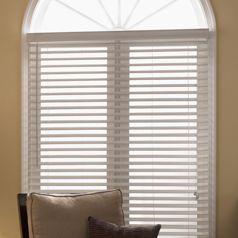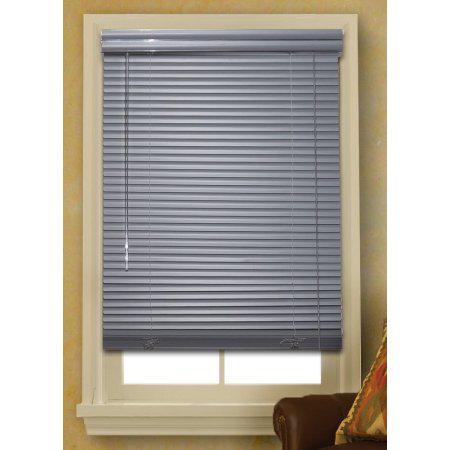The first image is the image on the left, the second image is the image on the right. Considering the images on both sides, is "The left and right image contains the same number of blinds." valid? Answer yes or no. No. The first image is the image on the left, the second image is the image on the right. For the images shown, is this caption "All of the window blinds are only partially open." true? Answer yes or no. No. 